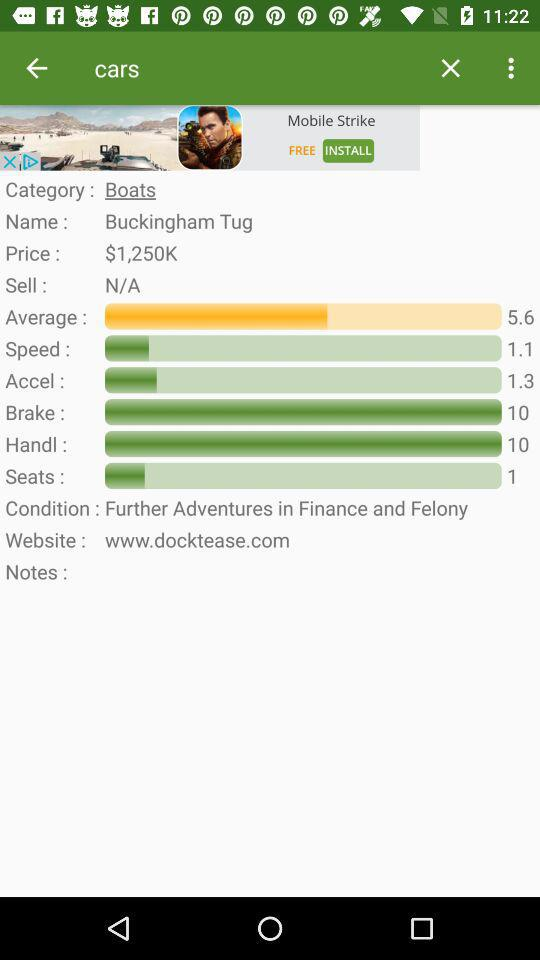What is the price? The price is $1,250K. 